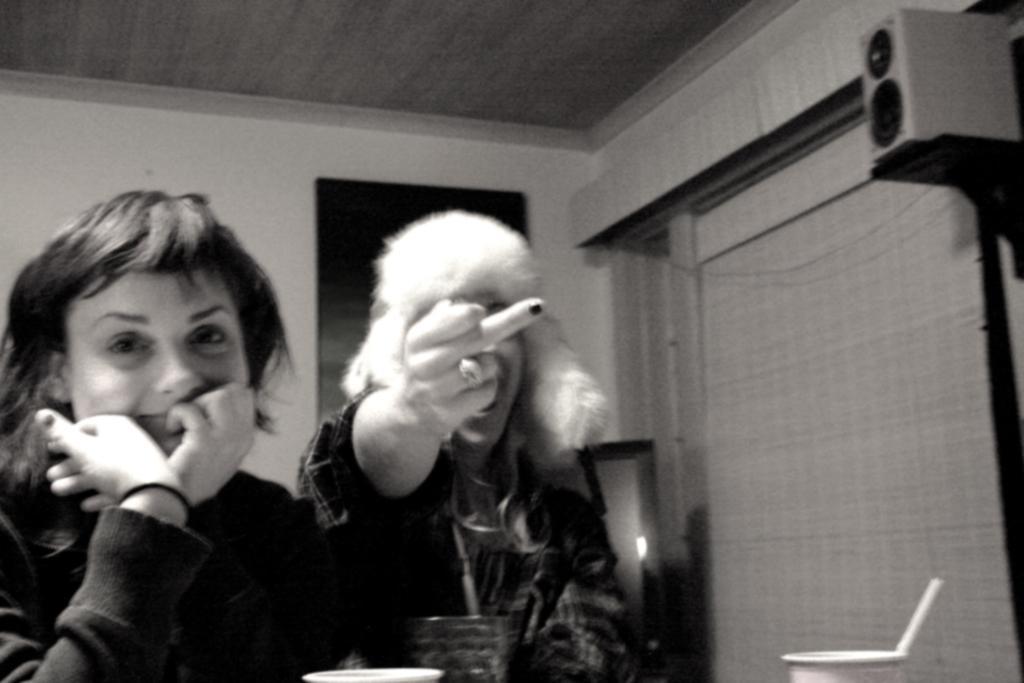In one or two sentences, can you explain what this image depicts? This is black and white picture where we can see two persons. To right side of the image one speaker is there. Bottom of the image glasses are present. 